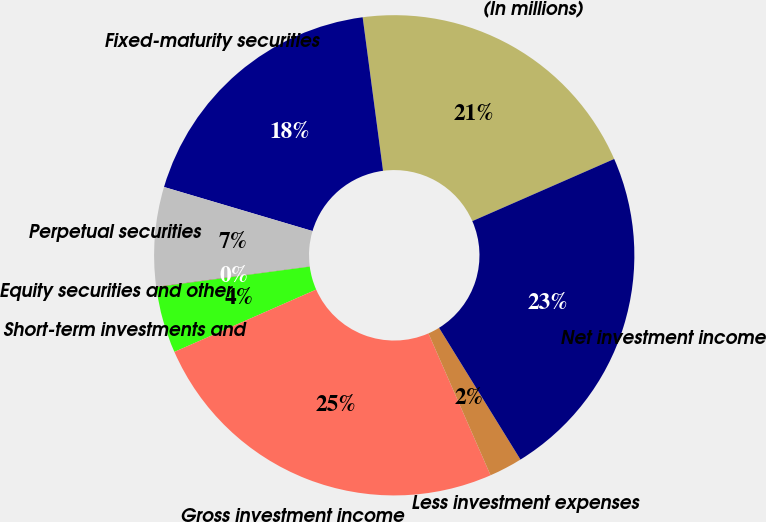Convert chart to OTSL. <chart><loc_0><loc_0><loc_500><loc_500><pie_chart><fcel>(In millions)<fcel>Fixed-maturity securities<fcel>Perpetual securities<fcel>Equity securities and other<fcel>Short-term investments and<fcel>Gross investment income<fcel>Less investment expenses<fcel>Net investment income<nl><fcel>20.53%<fcel>18.31%<fcel>6.69%<fcel>0.02%<fcel>4.47%<fcel>24.98%<fcel>2.24%<fcel>22.76%<nl></chart> 